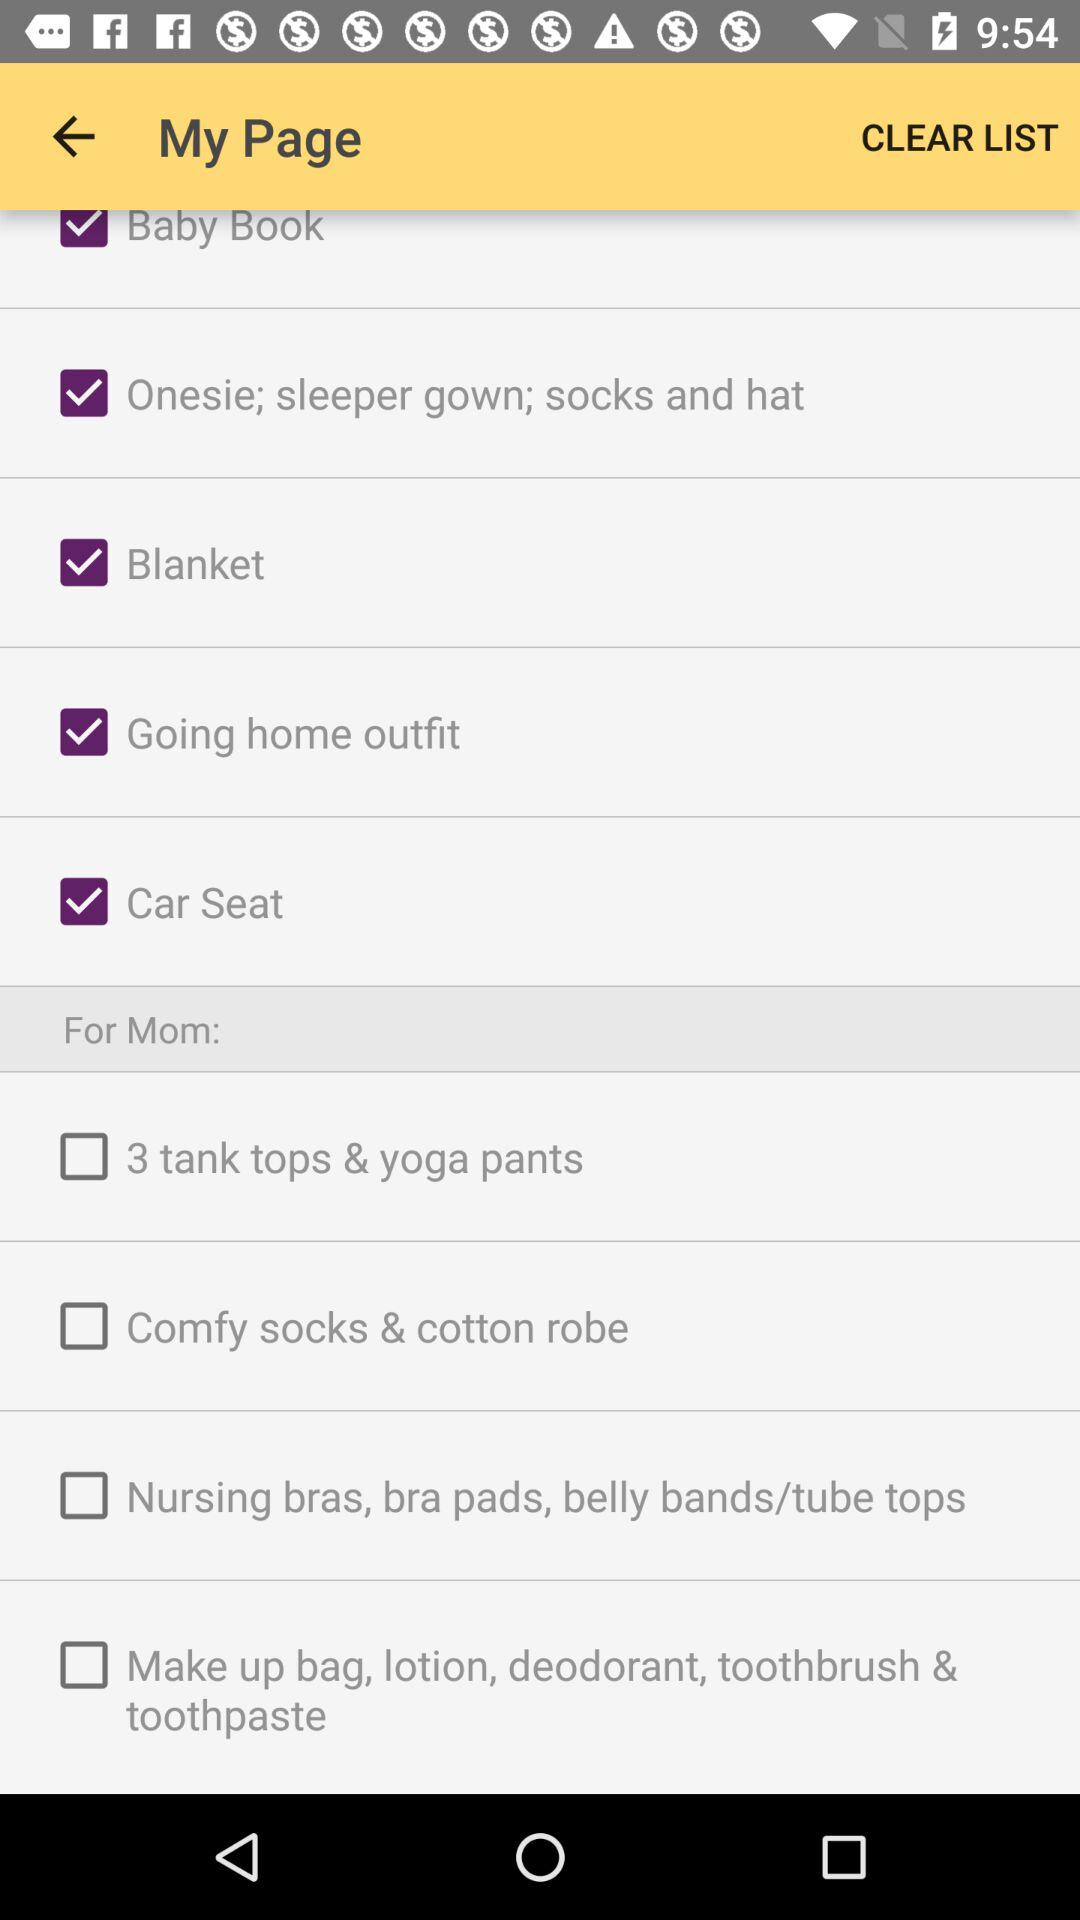How many items are there for the baby?
Answer the question using a single word or phrase. 5 